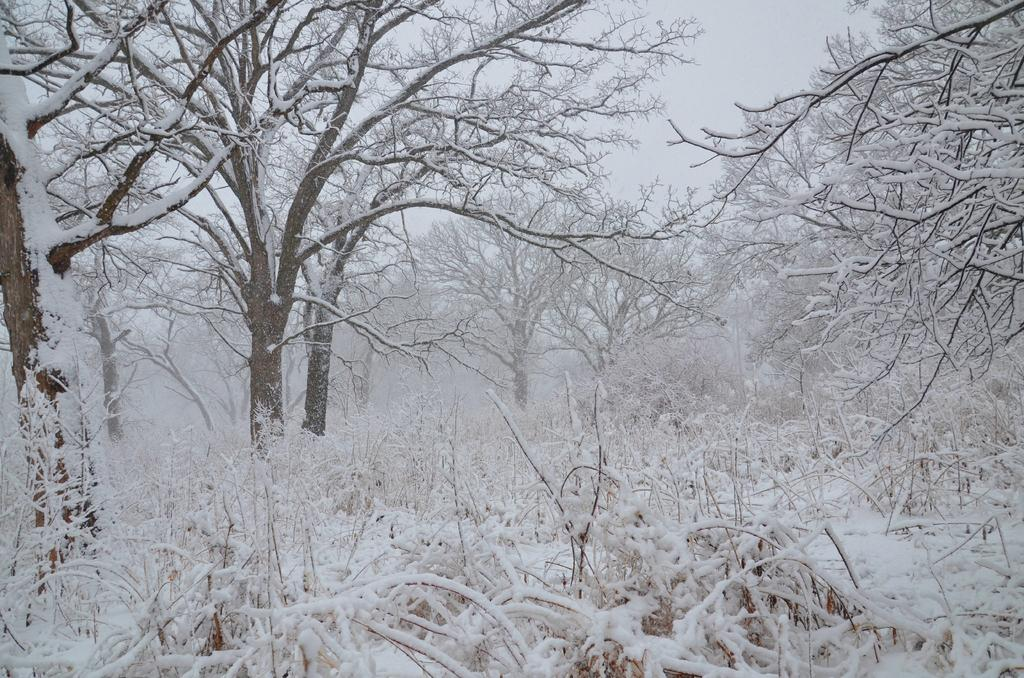What type of vegetation can be seen in the image? There are trees in the image. What is covering the ground in the image? There is snow visible in the image. What can be seen in the background of the image? The sky is visible in the background of the image. What type of memory is stored in the seed in the image? There is no seed present in the image, and therefore no memory can be associated with it. 